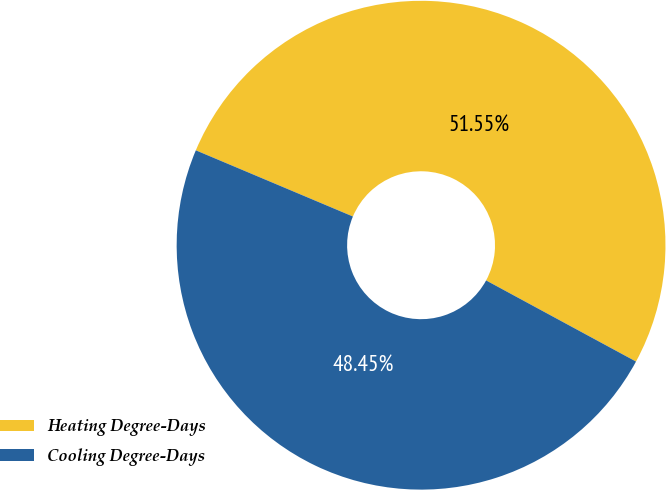<chart> <loc_0><loc_0><loc_500><loc_500><pie_chart><fcel>Heating Degree-Days<fcel>Cooling Degree-Days<nl><fcel>51.55%<fcel>48.45%<nl></chart> 